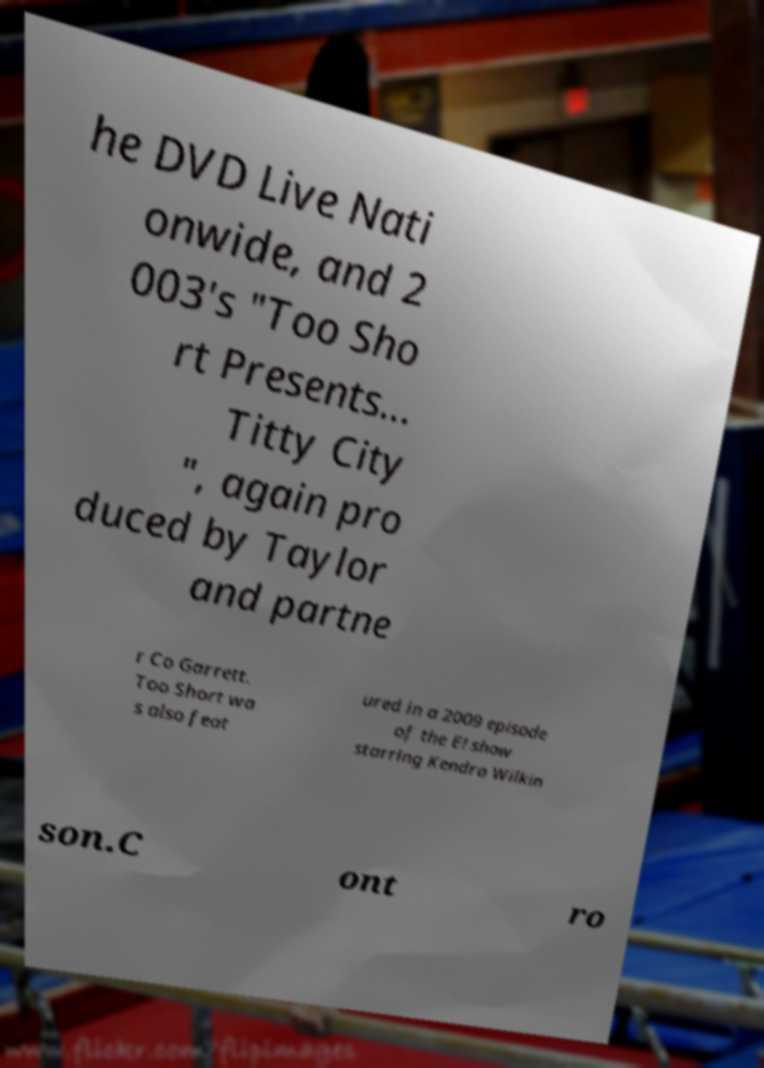What messages or text are displayed in this image? I need them in a readable, typed format. he DVD Live Nati onwide, and 2 003's "Too Sho rt Presents... Titty City ", again pro duced by Taylor and partne r Co Garrett. Too Short wa s also feat ured in a 2009 episode of the E! show starring Kendra Wilkin son.C ont ro 